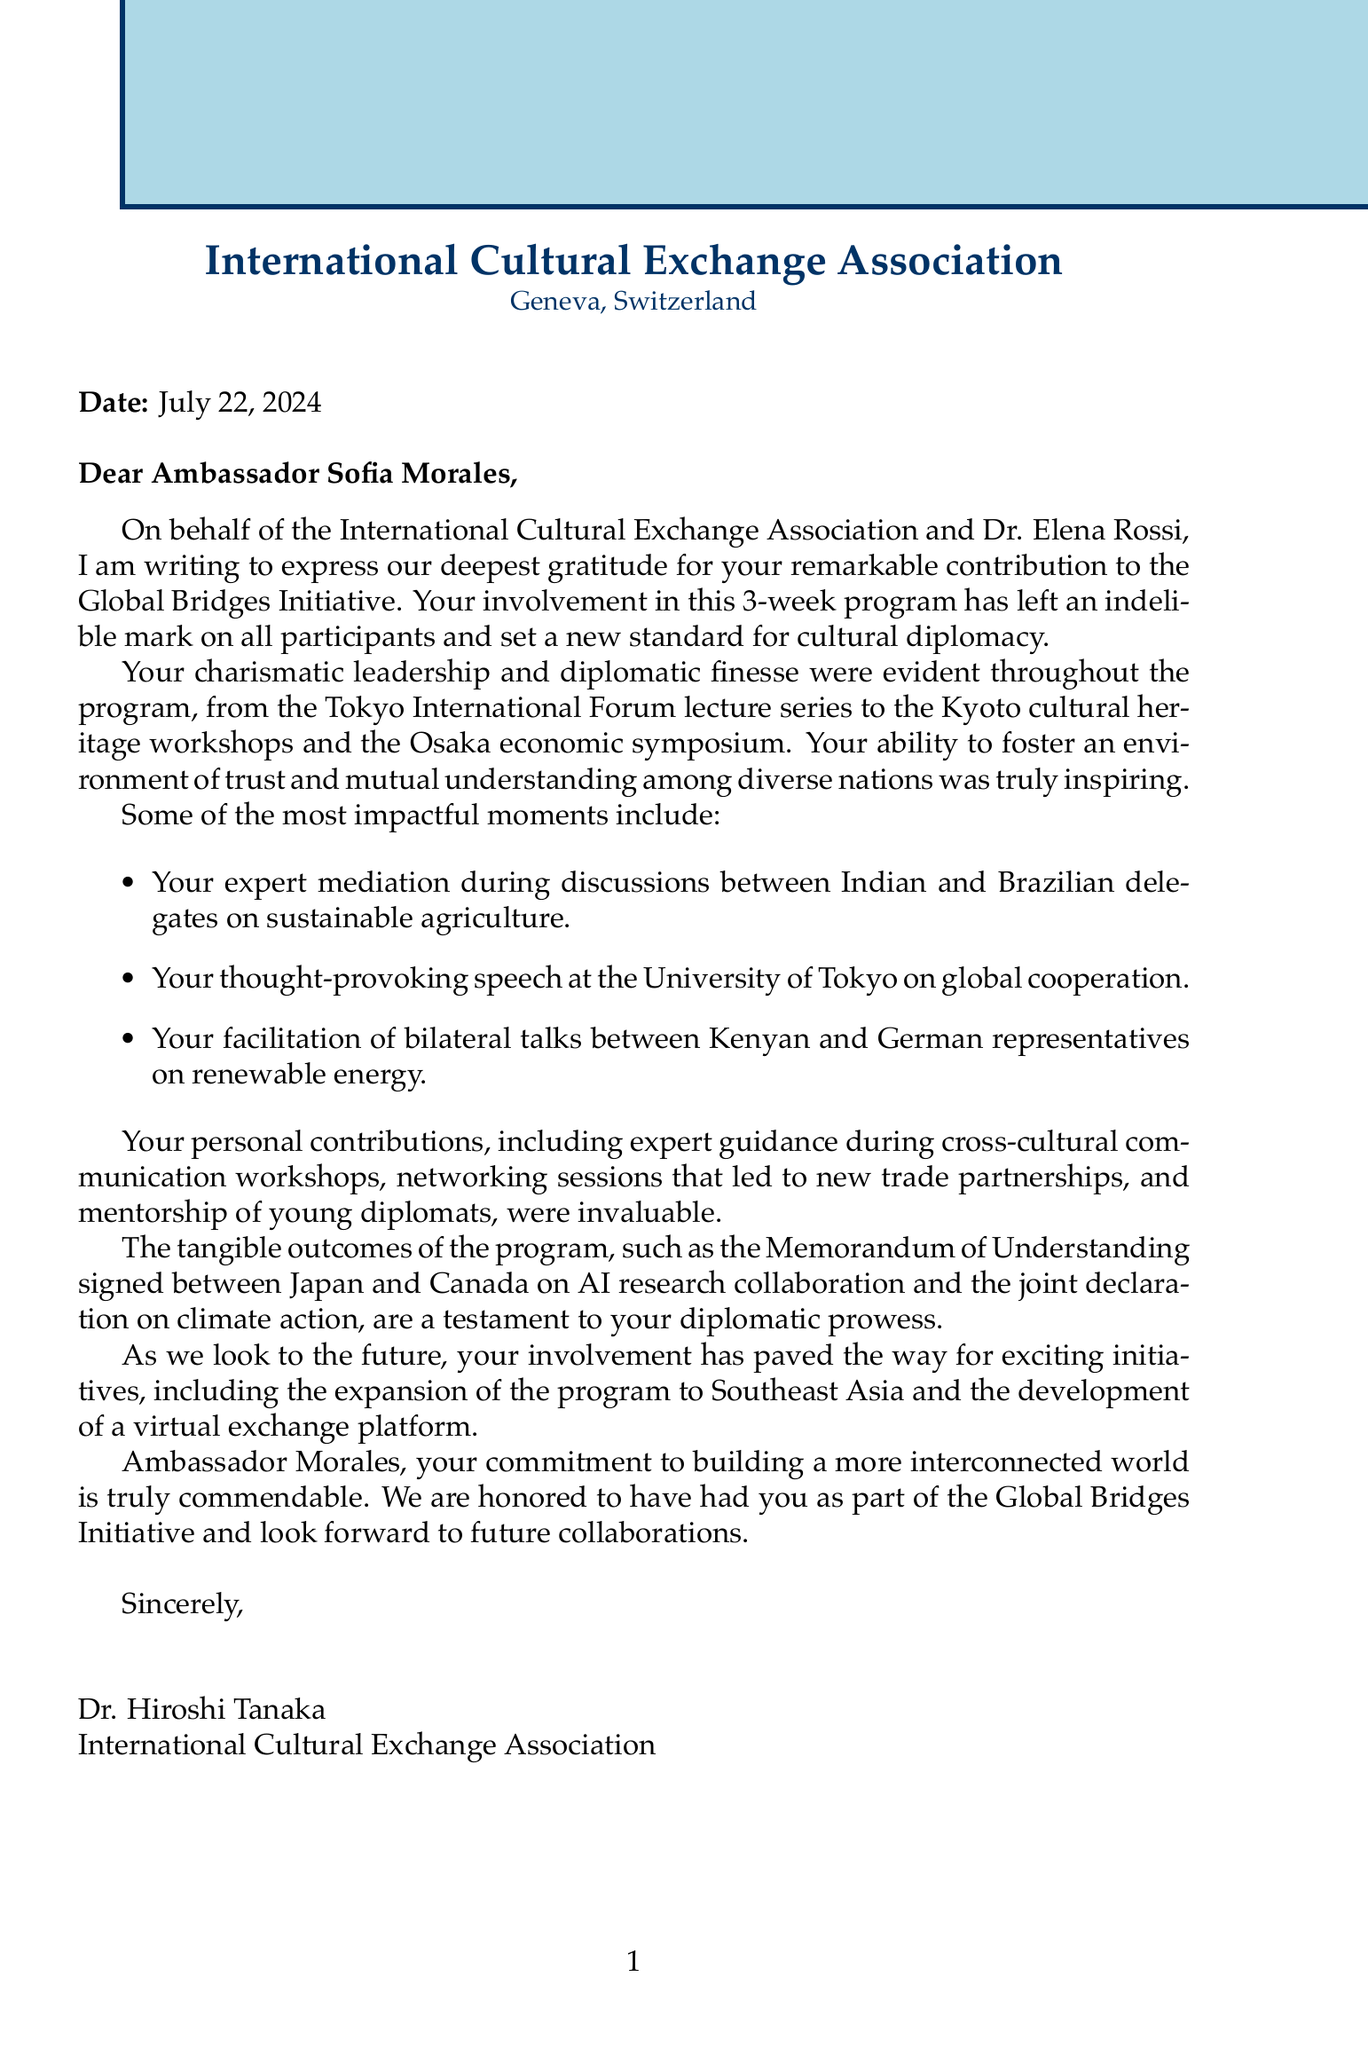What is the name of the sender? The sender of the letter is Dr. Hiroshi Tanaka.
Answer: Dr. Hiroshi Tanaka How many countries participated in the Global Bridges Initiative? The document lists five participating countries in the initiative.
Answer: 5 What is the host country for the program? The program took place in Japan, which is mentioned as the host country.
Answer: Japan What was one of the key events listed in the program? The document mentions several events, including the Tokyo International Forum lecture series.
Answer: Tokyo International Forum lecture series Which country signed a Memorandum of Understanding with Japan? The document states that Japan and Canada signed a Memorandum of Understanding.
Answer: Canada What was a significant moment involving bilateral talks? The document mentions that bilateral talks were facilitated between Kenyan and German representatives on renewable energy.
Answer: Renewable energy What is one of the future initiatives mentioned in the letter? The document discusses the expansion of the program to include more countries in Southeast Asia as a future initiative.
Answer: Expansion to Southeast Asia What organization is Dr. Hiroshi Tanaka associated with? The letter states that he is associated with the International Cultural Exchange Association.
Answer: International Cultural Exchange Association What is the overall tone of the letter? The tone of the letter is one of gratitude and appreciation for the ambassador's contributions.
Answer: Gratitude and appreciation 